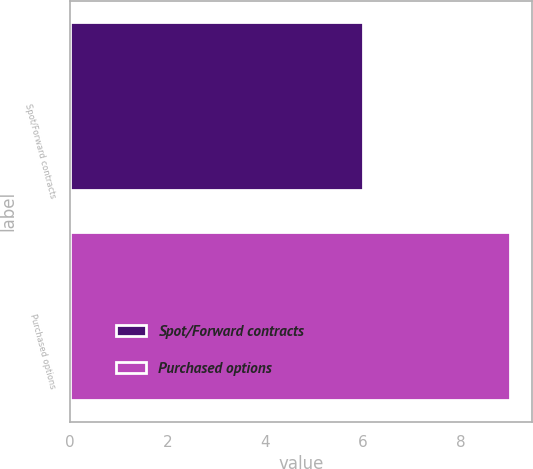<chart> <loc_0><loc_0><loc_500><loc_500><bar_chart><fcel>Spot/Forward contracts<fcel>Purchased options<nl><fcel>6<fcel>9<nl></chart> 